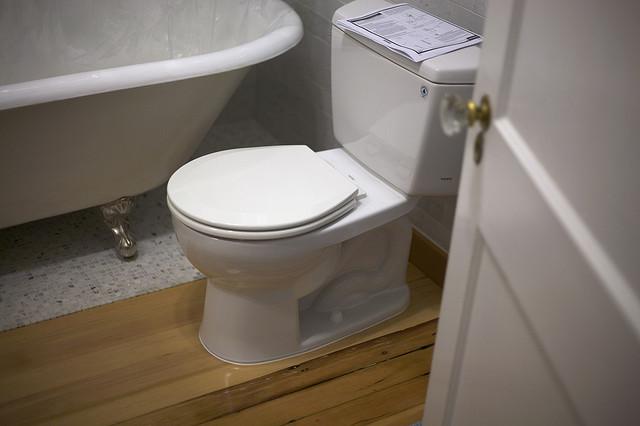What room is this?
Concise answer only. Bathroom. What type of tub is that?
Quick response, please. Claw foot. Do you a toilet cleaner?
Answer briefly. No. Is some of the floor material appear damaged?
Be succinct. Yes. 